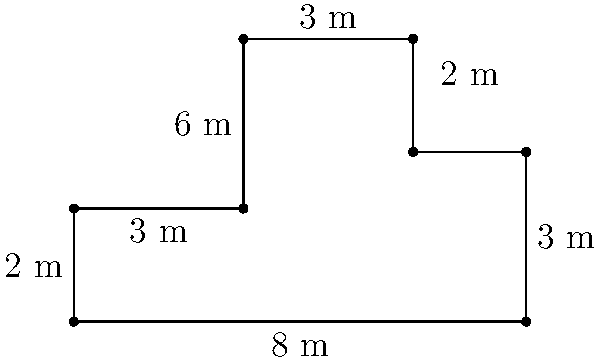As a factory worker, you've been asked to calculate the total floor area of your new irregularly shaped workspace. The floor plan is shown above, with all measurements in meters. What is the total area of this factory floor in square meters? To calculate the area of this irregular shape, we can break it down into rectangles:

1. Main rectangle: 
   Length = 8 m, Width = 2 m
   Area = $8 \times 2 = 16$ m²

2. Upper left rectangle:
   Length = 3 m, Width = 3 m
   Area = $3 \times 3 = 9$ m²

3. Upper right rectangle:
   Length = 2 m, Width = 3 m
   Area = $2 \times 3 = 6$ m²

4. Lower right rectangle:
   Length = 2 m, Width = 1 m
   Area = $2 \times 1 = 2$ m²

Total area is the sum of these rectangles:
$$16 + 9 + 6 + 2 = 33$$ m²

Therefore, the total area of the factory floor is 33 square meters.
Answer: 33 m² 